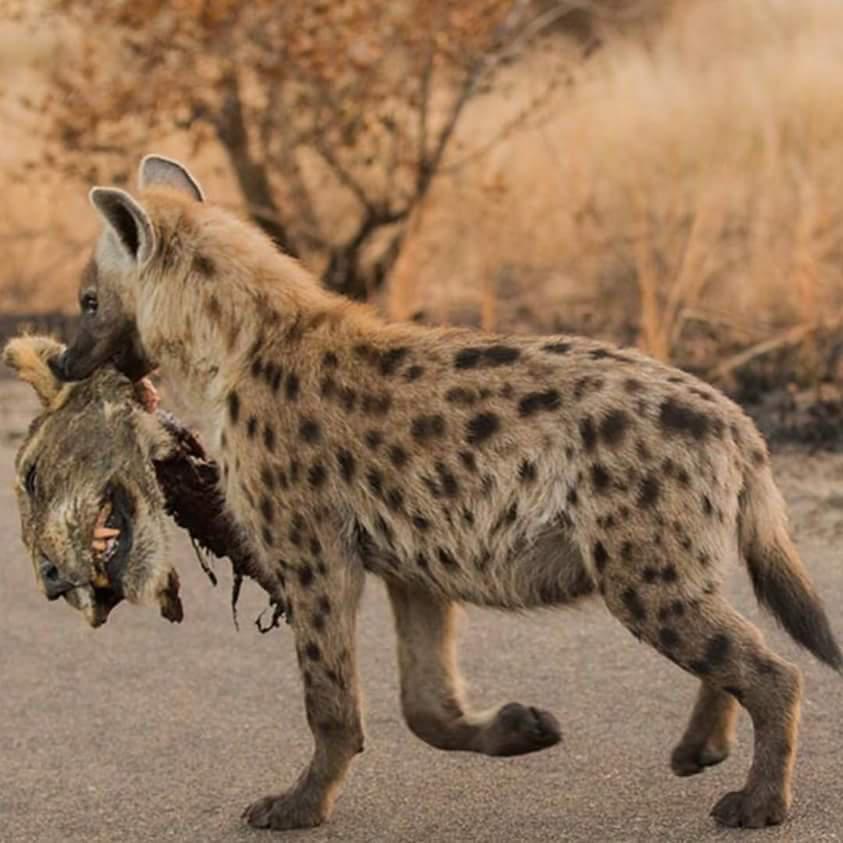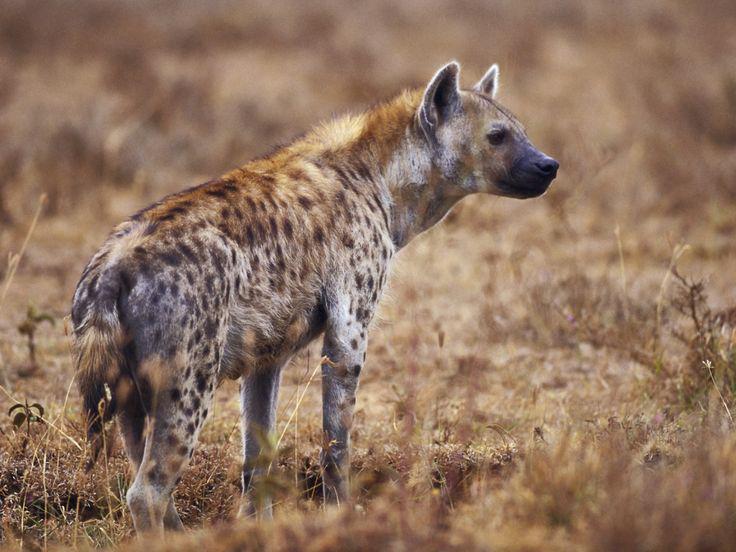The first image is the image on the left, the second image is the image on the right. Given the left and right images, does the statement "An image shows a hyena carrying prey in its jaws." hold true? Answer yes or no. Yes. 